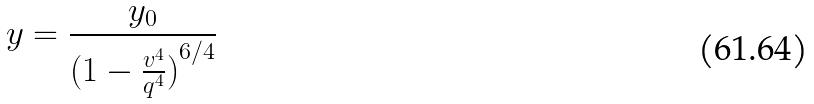<formula> <loc_0><loc_0><loc_500><loc_500>y = \frac { y _ { 0 } } { ( { 1 - \frac { v ^ { 4 } } { q ^ { 4 } } ) } ^ { 6 / 4 } }</formula> 